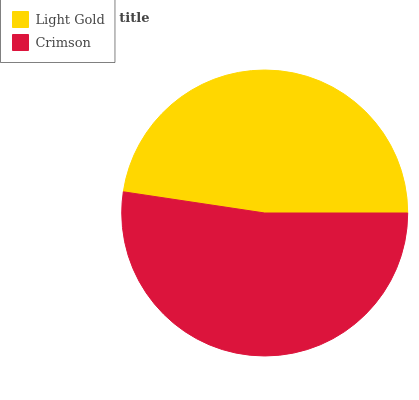Is Light Gold the minimum?
Answer yes or no. Yes. Is Crimson the maximum?
Answer yes or no. Yes. Is Crimson the minimum?
Answer yes or no. No. Is Crimson greater than Light Gold?
Answer yes or no. Yes. Is Light Gold less than Crimson?
Answer yes or no. Yes. Is Light Gold greater than Crimson?
Answer yes or no. No. Is Crimson less than Light Gold?
Answer yes or no. No. Is Crimson the high median?
Answer yes or no. Yes. Is Light Gold the low median?
Answer yes or no. Yes. Is Light Gold the high median?
Answer yes or no. No. Is Crimson the low median?
Answer yes or no. No. 